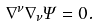<formula> <loc_0><loc_0><loc_500><loc_500>\nabla ^ { \nu } \nabla _ { \nu } \Psi = 0 .</formula> 